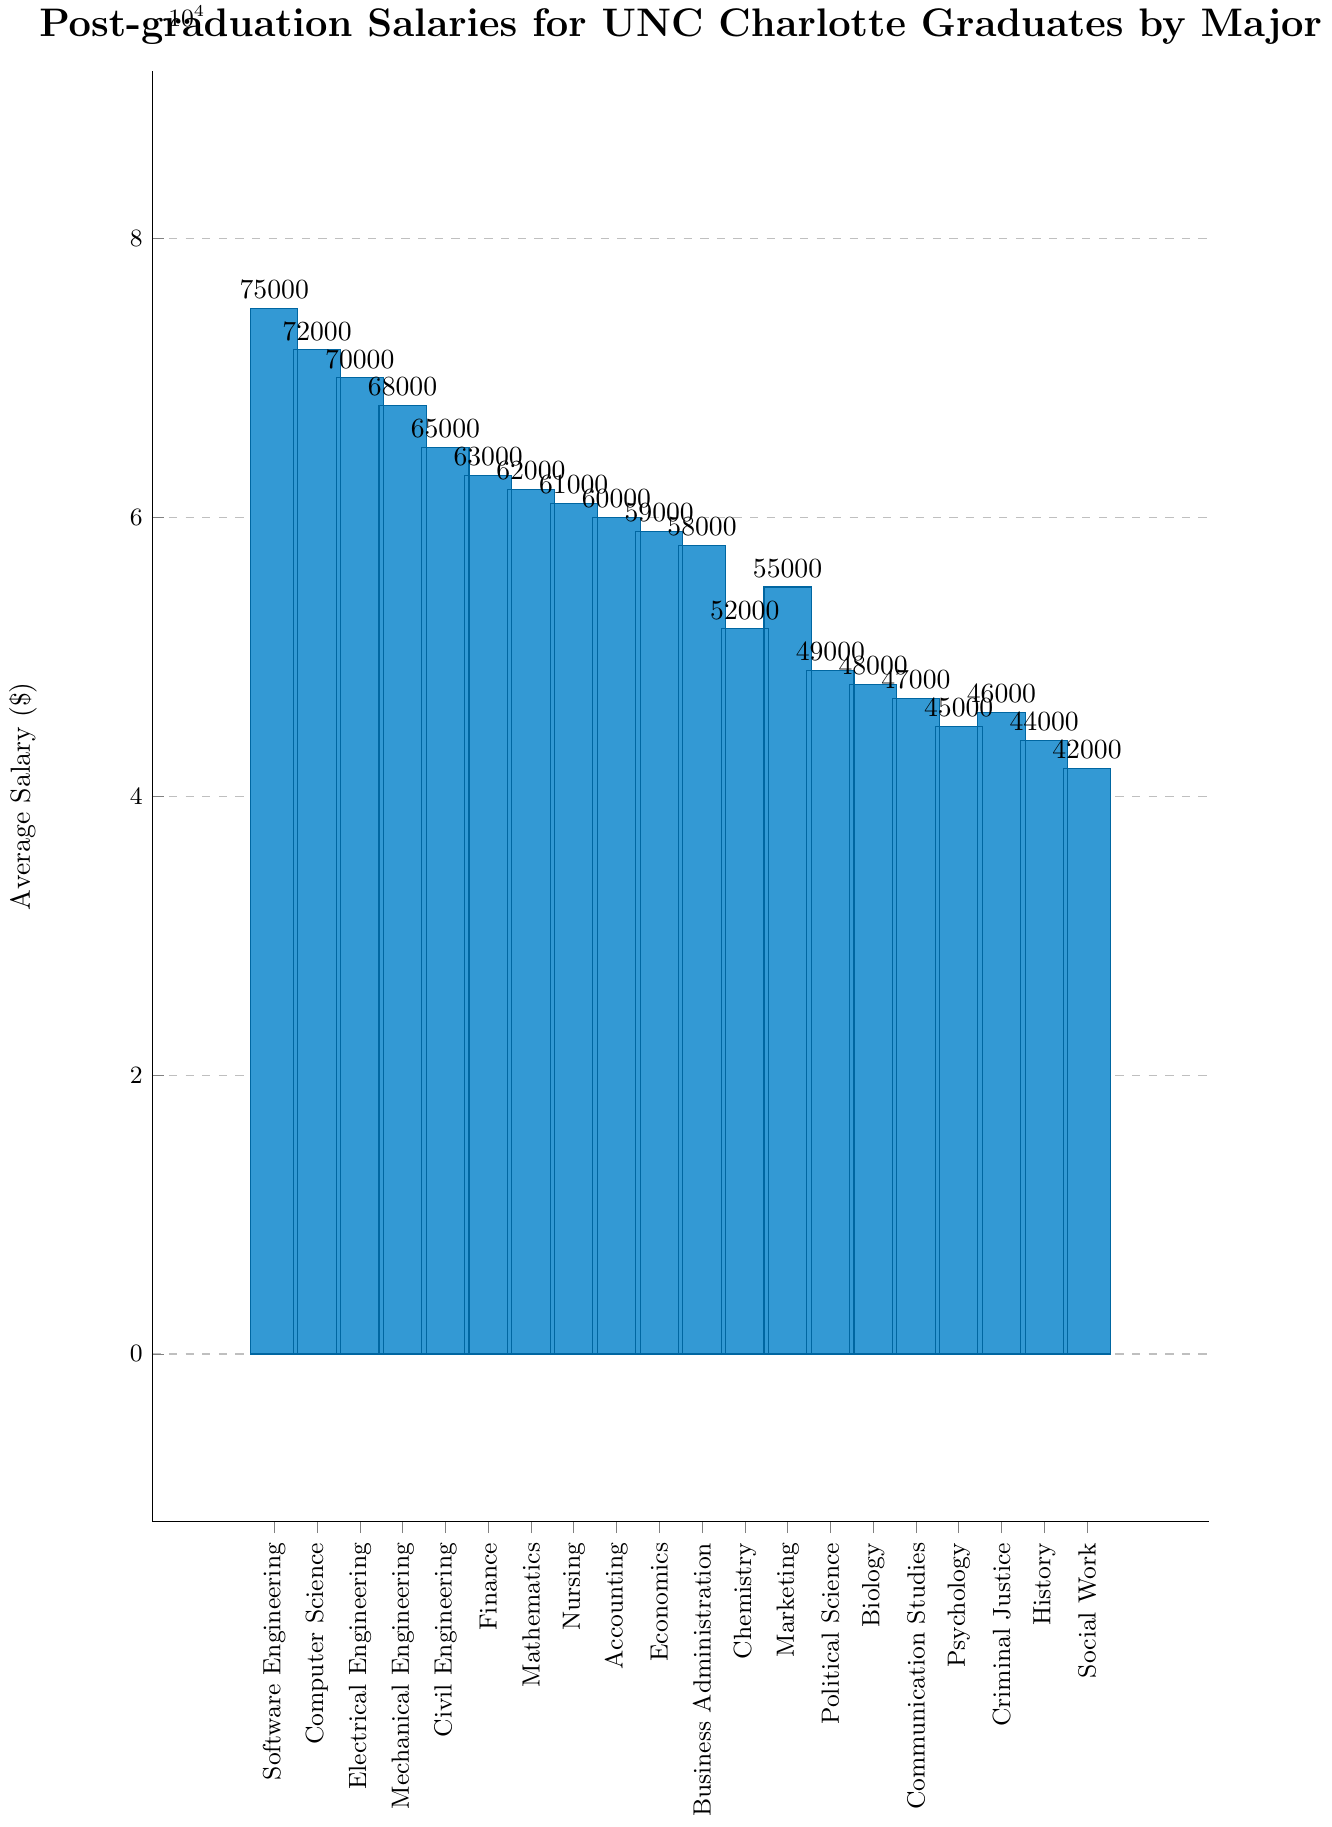What's the highest post-graduation salary among all majors? Look at the bar representing each major in the chart and compare their heights to identify the tallest one. The bar for Software Engineering is the highest with a value of $75,000.
Answer: $75,000 Which major has the lowest average post-graduation salary? Observe the shortest bar in the chart, which represents the Social Work major with a value of $42,000.
Answer: Social Work How much higher is the average salary of Software Engineering graduates compared to Nursing graduates? Identify the heights of the bars for Software Engineering ($75,000) and Nursing ($61,000). Subtract the Nursing salary from the Software Engineering salary: $75,000 - $61,000 = $14,000.
Answer: $14,000 What's the average salary for all the engineering majors combined (Mechanical, Electrical, Civil, Software)? Locate the average salaries for Mechanical ($68,000), Electrical ($70,000), Civil ($65,000), and Software ($75,000). Sum these values and divide by the number of engineering majors: ($68,000 + $70,000 + $65,000 + $75,000) / 4 = $69,500.
Answer: $69,500 Is the average salary for Business Administration graduates higher than that for Communication Studies graduates? Compare the heights of the bars for Business Administration ($58,000) and Communication Studies ($47,000). Business Administration is higher.
Answer: Yes What is the difference between the highest and lowest average post-graduation salaries? Identify the highest (Software Engineering, $75,000) and lowest (Social Work, $42,000) average salaries. Subtract the lowest from the highest: $75,000 - $42,000 = $33,000.
Answer: $33,000 How do the average salaries for Economics and Finance majors compare? Observe the bars for Economics ($59,000) and Finance ($63,000). The Finance bar is higher than the Economics bar.
Answer: Finance is higher Which major shows an average salary closest to $50,000? Identify the major whose bar reaches closest to the $50,000 mark. Political Science graduates have an average salary of $49,000, which is closest to $50,000.
Answer: Political Science Is the average salary for Mathematics graduates greater than the average salary for Chemistry graduates? Compare the heights of the bars for Mathematics ($62,000) and Chemistry ($52,000). Mathematics has a higher average salary.
Answer: Yes Among the listed majors, how many have an average salary above $60,000? Count the number of majors with bars extending above the $60,000 mark. These include Software Engineering, Computer Science, Electrical Engineering, Mechanical Engineering, Civil Engineering, Finance, Mathematics, and Nursing. There are 8 such majors.
Answer: 8 